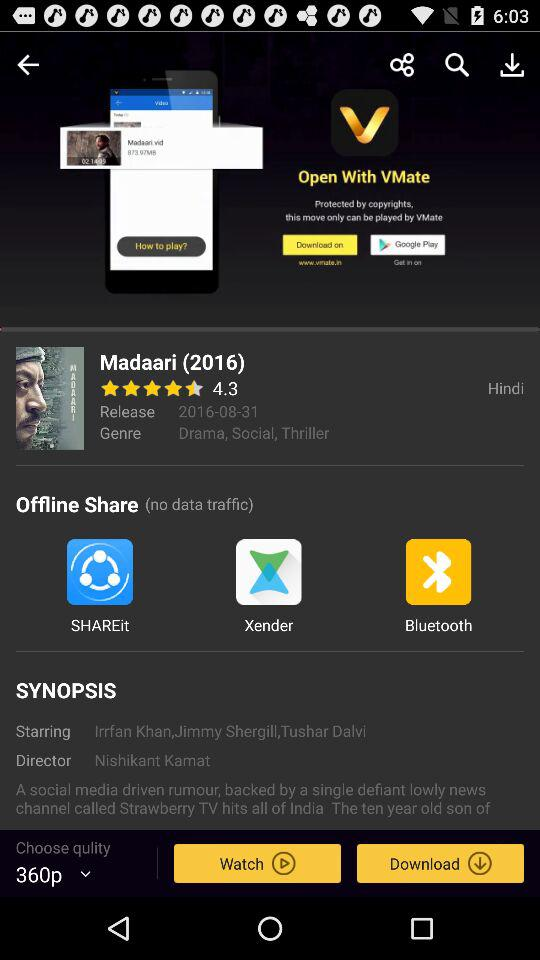What is the selected quality? The selected quality is 360p. 